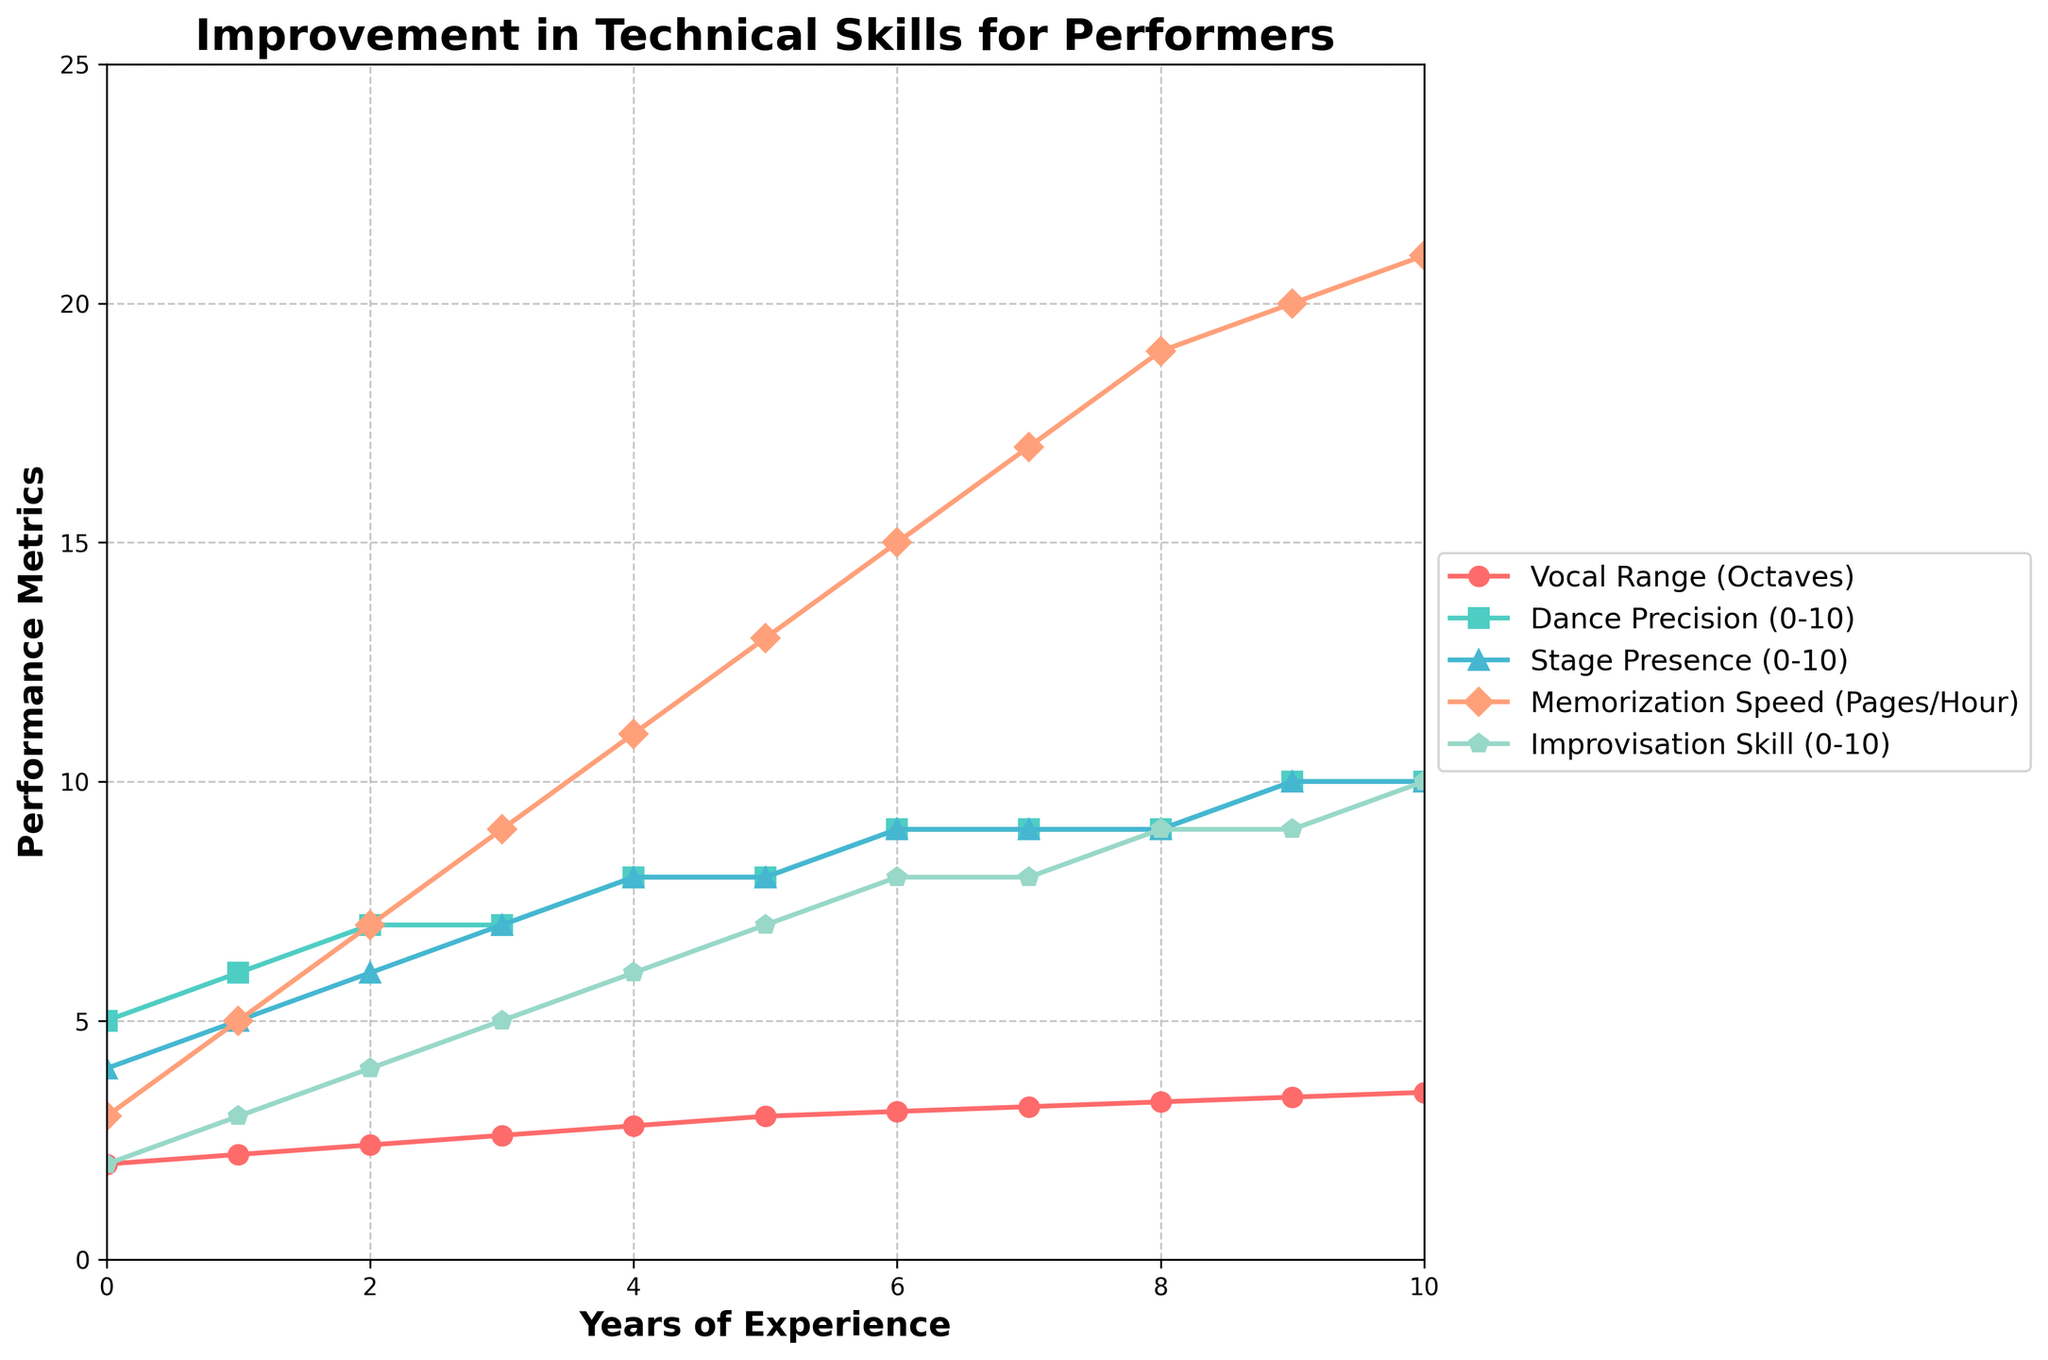What is the initial value of Vocal Range in Octaves? The initial value of Vocal Range in Octaves can be found at the starting point for "Years of Experience" which is 0. According to the data, the value is 2.0.
Answer: 2.0 Which metric shows the most improvement over the 10 years? To determine which metric shows the most improvement over the 10 years, compare the initial and final values for each metric. Vocal Range improves from 2.0 to 3.5, Dance Precision from 5 to 10, Stage Presence from 4 to 10, Memorization Speed from 3 to 21, and Improvisation Skill from 2 to 10. Memorization Speed has the highest increase, from 3 to 21.
Answer: Memorization Speed Is there any metric that reaches its maximum score and when does it happen? Check if any metric hits its highest value and when that occurs. Dance Precision and Stage Presence both reach a score of 10. Dance Precision first hits 10 at year 9, and Stage Presence hits 10 at year 9 as well.
Answer: Dance Precision and Stage Presence at year 9 What is the value of Dance Precision at 5 years of experience? Look at the plot to find the value of Dance Precision at 5 years on the x-axis. According to the data, at 5 years, Dance Precision is 8.
Answer: 8 By how many units does Improvisation Skill increase between 3 and 6 years of experience? To find the increase, subtract the value at 3 years from the value at 6 years for Improvisation Skill. The values are 5 at year 3 and 8 at year 6. The difference is 8 - 5 = 3.
Answer: 3 How does Dance Precision compare to Vocal Range in Year 4? Compare the values of Dance Precision and Vocal Range at year 4. Dance Precision is 8, and Vocal Range is 2.8 at year 4.
Answer: Dance Precision is greater If we average the Stage Presence values from years 2, 4, and 6, what is the result? Calculate the average of Stage Presence values at years 2, 4, and 6. The values are 6, 8, and 9 respectively. The sum is 6 + 8 + 9 = 23, and the average is 23 / 3 = 7.67.
Answer: 7.67 Which metric stabilizes first, and in which year? A metric that stabilizes remains constant thereafter. By visual inspection, Dance Precision stabilizes first at year 7, staying at 9 until year 8 before reaching 10.
Answer: Dance Precision, 7 How does the Vocal Range change from years 8 to 10? To determine the change in Vocal Range from year 8 to year 10, look at the values: 3.3 at year 8, 3.4 at year 9, and 3.5 at year 10, indicating an increase of 0.2 each year.
Answer: Increases by 0.2 per year Which metric shows the most sudden increase in value between consecutive years, and what are those years? Look for the steepest rise between consecutive years for any metric. Memorization Speed shows an increase from 11 to 13 between years 4 and 5, an increase of 2 units. This is the same between years 5 and 6, 6 and 7, 7 and 8, and the largest increase seen in the data.
Answer: Memorization Speed, between years 4 and 5 